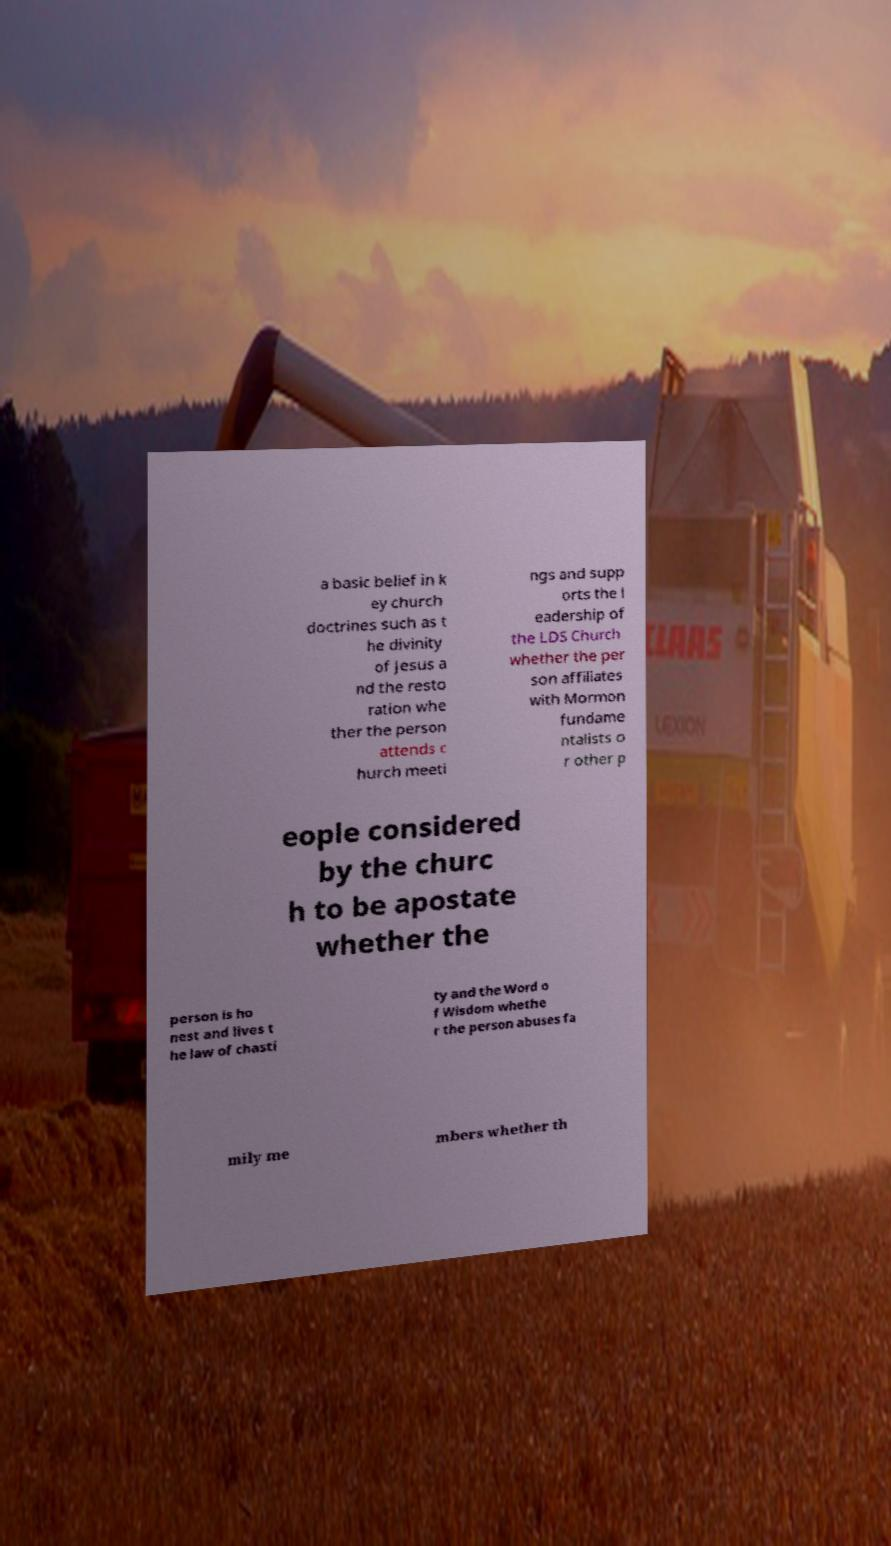For documentation purposes, I need the text within this image transcribed. Could you provide that? a basic belief in k ey church doctrines such as t he divinity of Jesus a nd the resto ration whe ther the person attends c hurch meeti ngs and supp orts the l eadership of the LDS Church whether the per son affiliates with Mormon fundame ntalists o r other p eople considered by the churc h to be apostate whether the person is ho nest and lives t he law of chasti ty and the Word o f Wisdom whethe r the person abuses fa mily me mbers whether th 